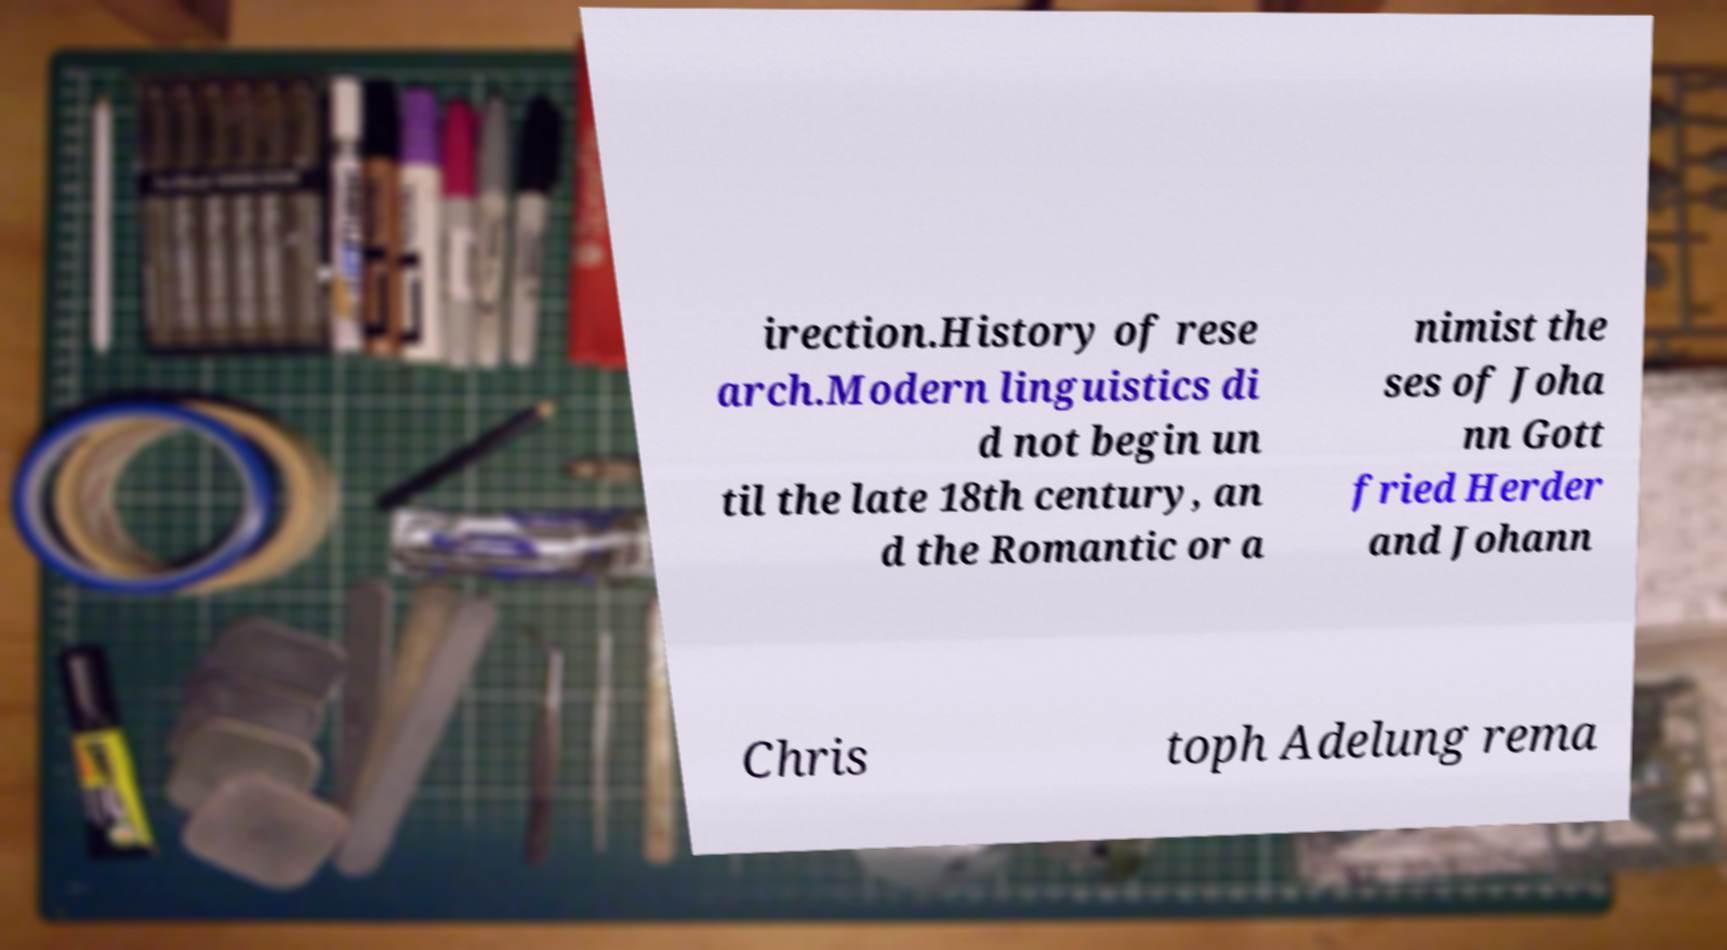I need the written content from this picture converted into text. Can you do that? irection.History of rese arch.Modern linguistics di d not begin un til the late 18th century, an d the Romantic or a nimist the ses of Joha nn Gott fried Herder and Johann Chris toph Adelung rema 